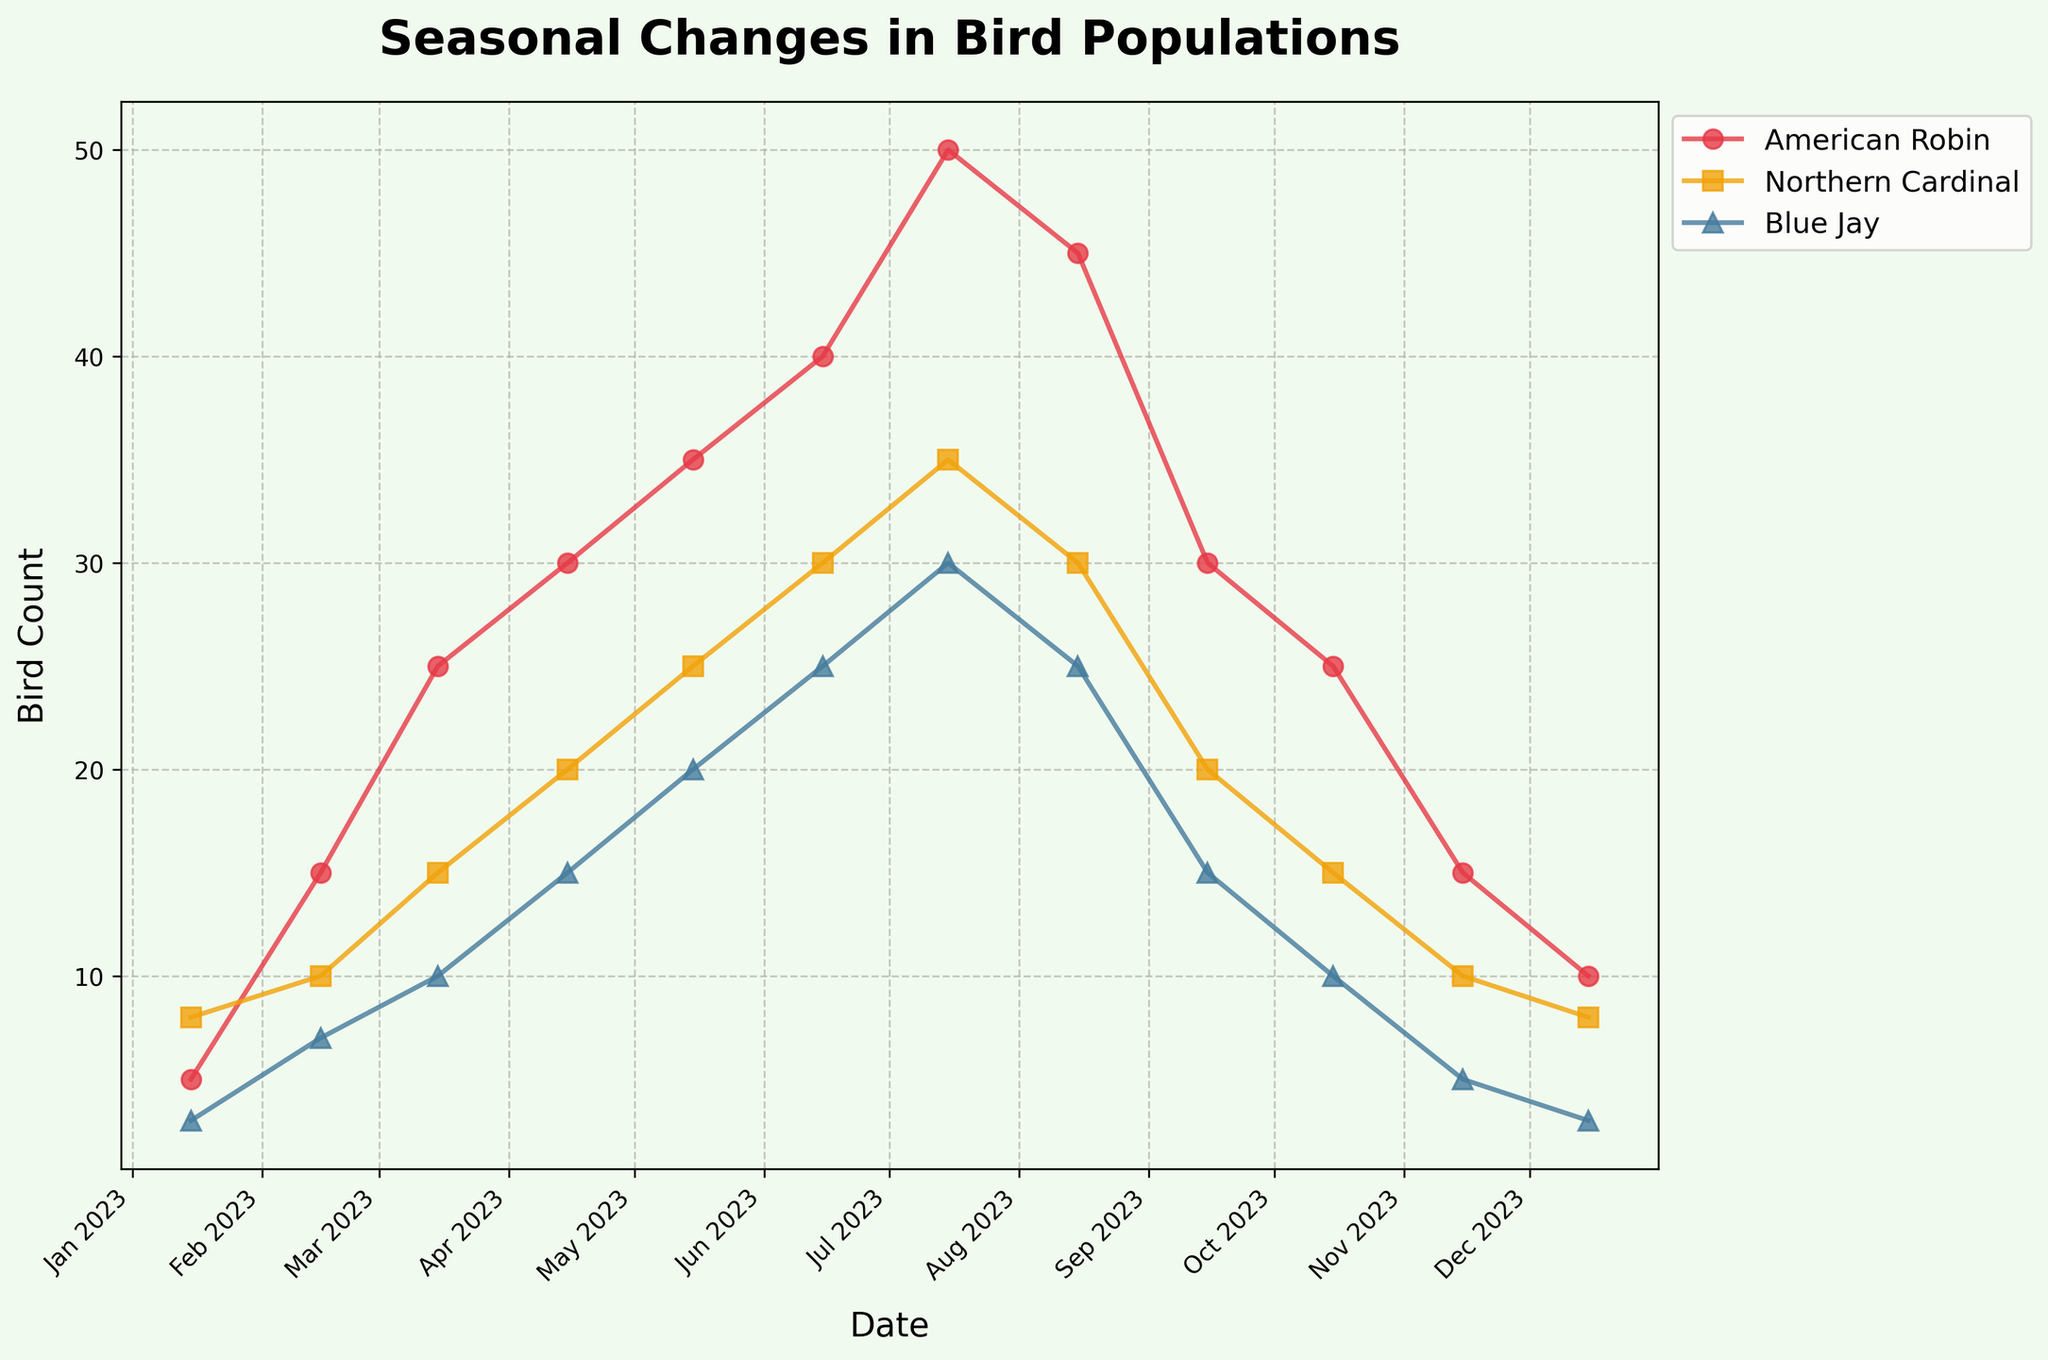What is the title of the plot? The title of the plot is displayed prominently above the chart.
Answer: Seasonal Changes in Bird Populations How many species of birds are represented in the plot? The plot shows three distinct lines, each labeled with a different species of bird.
Answer: Three Which bird species has the highest population in July? By looking at the number of data points for each species and identifying the one with the highest value in July, it's clear that the American Robin has the highest count.
Answer: American Robin How does the population of the American Robin change from January to July? To find this, examine the data points for the American Robin at the start (January) and midway through the year (July). The count increases from 5 to 50.
Answer: Increases Describe the trend for the Blue Jay's population over the year. Observing the data points for the Blue Jay reveals a steady increase in numbers from January to July, followed by a decline back to the initial count by December.
Answer: Increases then decreases Which month shows the highest overall bird count for all species combined? Sum the counts of all three bird species for each month and compare them. July has the highest combined total with 50 (American Robin) + 35 (Northern Cardinal) + 30 (Blue Jay) = 115.
Answer: July What is the general trend for the American Robin's population throughout the year? Tracking the American Robin's data points over the year shows a steady increase peaking in July, followed by a decline towards December.
Answer: Peaks in July then declines Is there a month where all three species show a declining trend from the previous month? Compare the bird counts for every month and note any month where all three species have lower counts than the previous month. This happens in August.
Answer: August Between which months does the Northern Cardinal's population remain constant? By identifying the Northern Cardinal's data points, it's observed that the population remains constant between February and March at 10 birds each.
Answer: February to March What is the difference in the bird count of the Northern Cardinal between its highest and lowest points? Identify the highest count in July (35) and the lowest in January (8); the difference is 35 - 8 = 27.
Answer: 27 